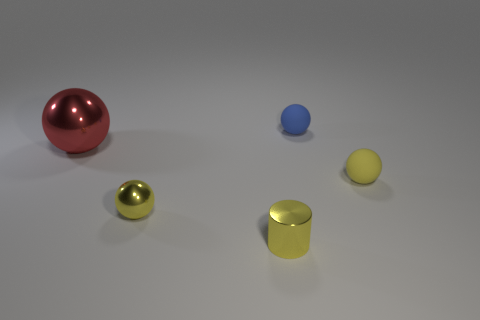Are the large sphere and the small object that is right of the blue matte ball made of the same material?
Your answer should be very brief. No. The red thing that is made of the same material as the yellow cylinder is what size?
Your answer should be compact. Large. Are there more large shiny objects that are in front of the big red object than big objects that are in front of the blue matte sphere?
Give a very brief answer. No. Is there another large red thing of the same shape as the large red object?
Offer a very short reply. No. There is a yellow cylinder to the left of the blue ball; is it the same size as the yellow metallic ball?
Ensure brevity in your answer.  Yes. Are any tiny blue matte things visible?
Your answer should be very brief. Yes. What number of objects are yellow spheres that are to the right of the tiny yellow metal cylinder or big red metal balls?
Your answer should be compact. 2. There is a small cylinder; does it have the same color as the large ball behind the small yellow metal cylinder?
Provide a succinct answer. No. Is there a yellow metal cylinder of the same size as the red shiny ball?
Provide a succinct answer. No. What is the yellow sphere left of the tiny matte thing that is in front of the blue matte ball made of?
Your answer should be very brief. Metal. 